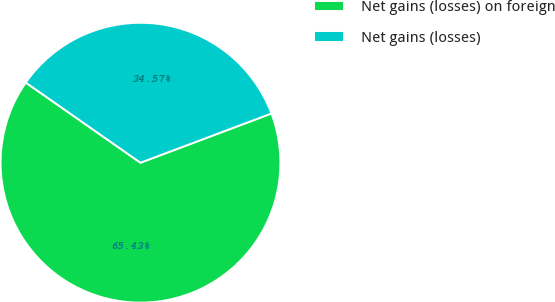Convert chart. <chart><loc_0><loc_0><loc_500><loc_500><pie_chart><fcel>Net gains (losses) on foreign<fcel>Net gains (losses)<nl><fcel>65.43%<fcel>34.57%<nl></chart> 